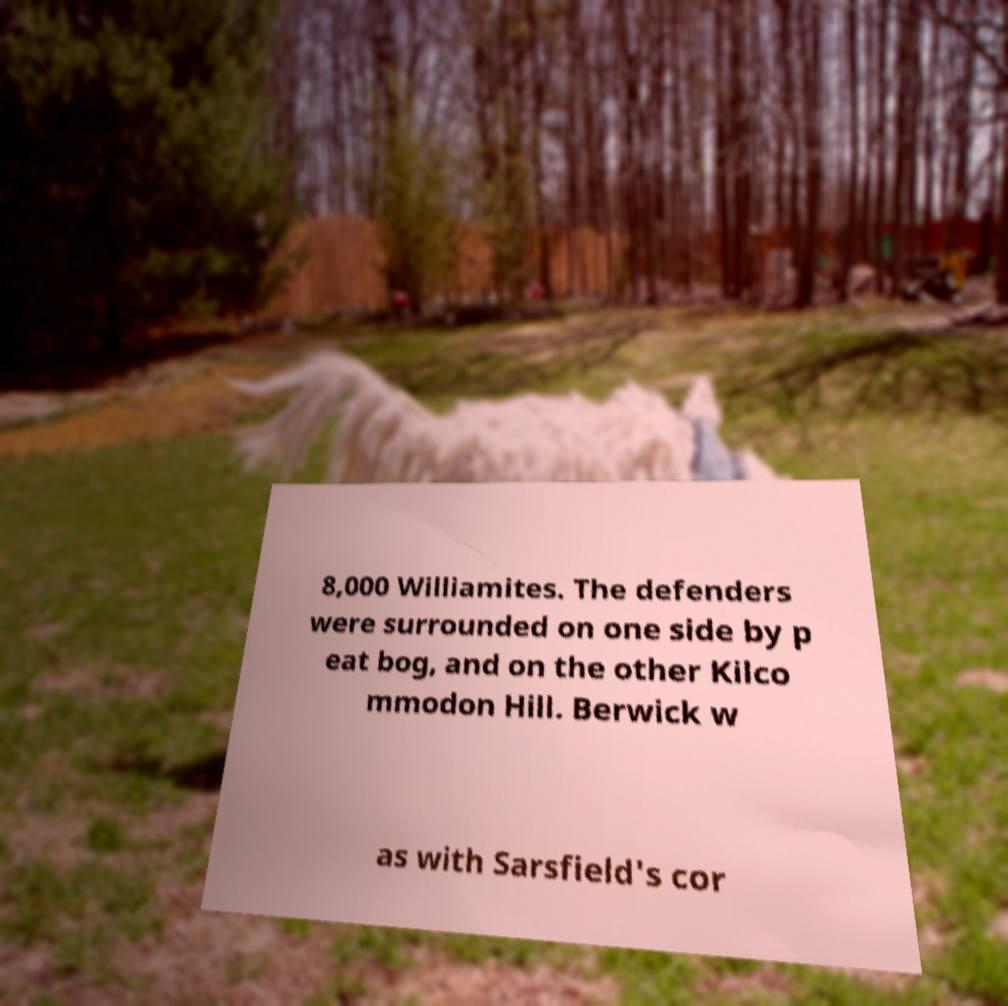I need the written content from this picture converted into text. Can you do that? 8,000 Williamites. The defenders were surrounded on one side by p eat bog, and on the other Kilco mmodon Hill. Berwick w as with Sarsfield's cor 